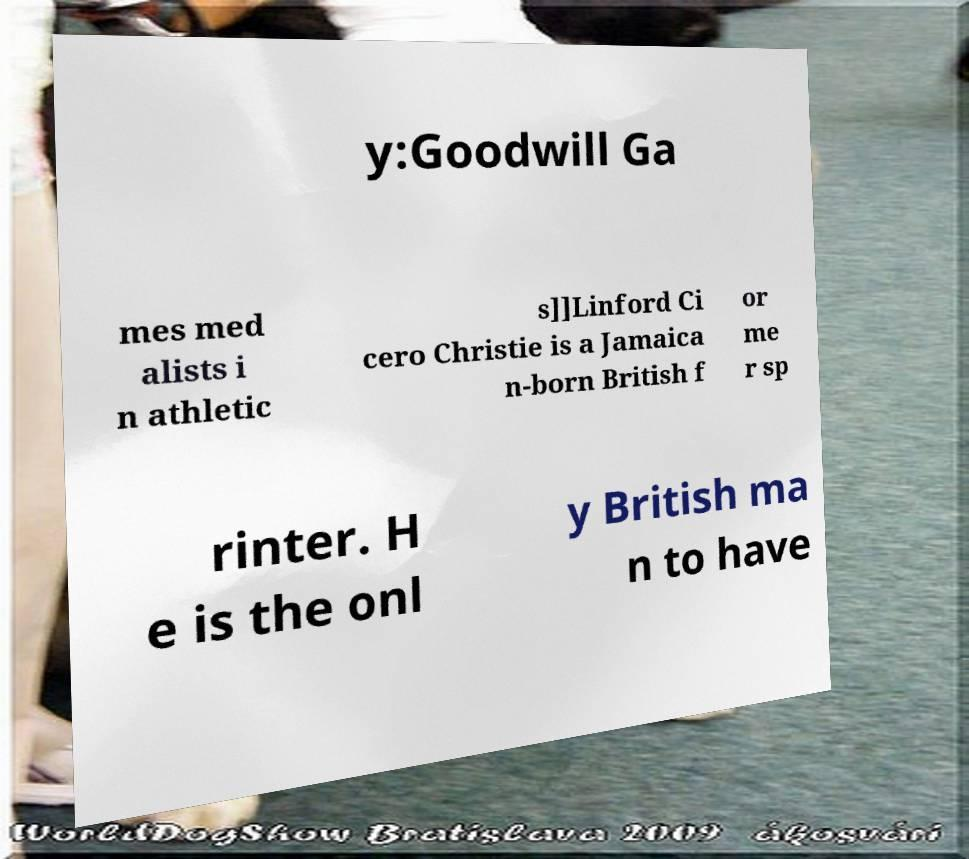Can you accurately transcribe the text from the provided image for me? y:Goodwill Ga mes med alists i n athletic s]]Linford Ci cero Christie is a Jamaica n-born British f or me r sp rinter. H e is the onl y British ma n to have 